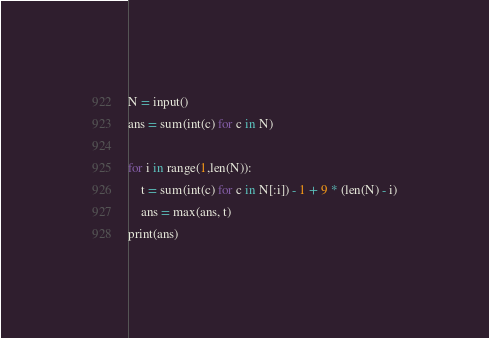Convert code to text. <code><loc_0><loc_0><loc_500><loc_500><_Python_>N = input()
ans = sum(int(c) for c in N)

for i in range(1,len(N)):
    t = sum(int(c) for c in N[:i]) - 1 + 9 * (len(N) - i)
    ans = max(ans, t)
print(ans)</code> 